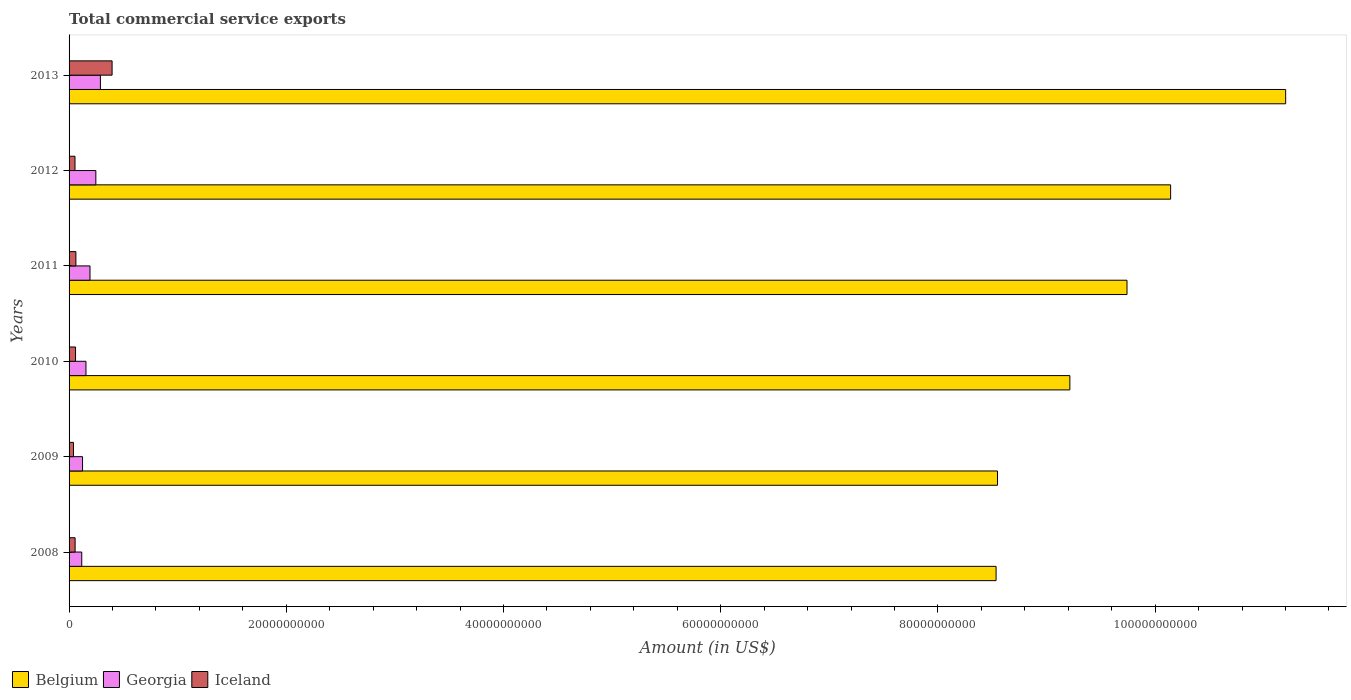Are the number of bars on each tick of the Y-axis equal?
Ensure brevity in your answer.  Yes. How many bars are there on the 5th tick from the top?
Provide a succinct answer. 3. How many bars are there on the 1st tick from the bottom?
Your answer should be compact. 3. What is the total commercial service exports in Iceland in 2010?
Ensure brevity in your answer.  5.96e+08. Across all years, what is the maximum total commercial service exports in Belgium?
Keep it short and to the point. 1.12e+11. Across all years, what is the minimum total commercial service exports in Georgia?
Your answer should be compact. 1.17e+09. In which year was the total commercial service exports in Belgium minimum?
Provide a short and direct response. 2008. What is the total total commercial service exports in Belgium in the graph?
Make the answer very short. 5.74e+11. What is the difference between the total commercial service exports in Belgium in 2009 and that in 2011?
Provide a succinct answer. -1.19e+1. What is the difference between the total commercial service exports in Georgia in 2010 and the total commercial service exports in Belgium in 2009?
Provide a short and direct response. -8.39e+1. What is the average total commercial service exports in Belgium per year?
Provide a short and direct response. 9.56e+1. In the year 2009, what is the difference between the total commercial service exports in Iceland and total commercial service exports in Georgia?
Ensure brevity in your answer.  -8.35e+08. In how many years, is the total commercial service exports in Iceland greater than 76000000000 US$?
Your answer should be very brief. 0. What is the ratio of the total commercial service exports in Belgium in 2011 to that in 2013?
Your response must be concise. 0.87. Is the total commercial service exports in Belgium in 2010 less than that in 2012?
Make the answer very short. Yes. What is the difference between the highest and the second highest total commercial service exports in Iceland?
Offer a terse response. 3.33e+09. What is the difference between the highest and the lowest total commercial service exports in Belgium?
Ensure brevity in your answer.  2.67e+1. What does the 1st bar from the bottom in 2012 represents?
Your answer should be very brief. Belgium. Are all the bars in the graph horizontal?
Provide a short and direct response. Yes. How many years are there in the graph?
Make the answer very short. 6. Are the values on the major ticks of X-axis written in scientific E-notation?
Offer a very short reply. No. Does the graph contain any zero values?
Provide a succinct answer. No. Does the graph contain grids?
Provide a short and direct response. No. How many legend labels are there?
Keep it short and to the point. 3. How are the legend labels stacked?
Offer a very short reply. Horizontal. What is the title of the graph?
Provide a succinct answer. Total commercial service exports. What is the Amount (in US$) of Belgium in 2008?
Offer a very short reply. 8.54e+1. What is the Amount (in US$) of Georgia in 2008?
Provide a short and direct response. 1.17e+09. What is the Amount (in US$) of Iceland in 2008?
Make the answer very short. 5.57e+08. What is the Amount (in US$) in Belgium in 2009?
Make the answer very short. 8.55e+1. What is the Amount (in US$) of Georgia in 2009?
Offer a terse response. 1.24e+09. What is the Amount (in US$) in Iceland in 2009?
Provide a succinct answer. 4.06e+08. What is the Amount (in US$) of Belgium in 2010?
Your answer should be very brief. 9.21e+1. What is the Amount (in US$) in Georgia in 2010?
Give a very brief answer. 1.56e+09. What is the Amount (in US$) of Iceland in 2010?
Offer a terse response. 5.96e+08. What is the Amount (in US$) of Belgium in 2011?
Provide a succinct answer. 9.74e+1. What is the Amount (in US$) in Georgia in 2011?
Give a very brief answer. 1.93e+09. What is the Amount (in US$) in Iceland in 2011?
Ensure brevity in your answer.  6.29e+08. What is the Amount (in US$) in Belgium in 2012?
Your response must be concise. 1.01e+11. What is the Amount (in US$) of Georgia in 2012?
Your answer should be very brief. 2.47e+09. What is the Amount (in US$) of Iceland in 2012?
Ensure brevity in your answer.  5.46e+08. What is the Amount (in US$) of Belgium in 2013?
Your answer should be very brief. 1.12e+11. What is the Amount (in US$) in Georgia in 2013?
Make the answer very short. 2.89e+09. What is the Amount (in US$) of Iceland in 2013?
Your answer should be very brief. 3.96e+09. Across all years, what is the maximum Amount (in US$) in Belgium?
Your answer should be compact. 1.12e+11. Across all years, what is the maximum Amount (in US$) in Georgia?
Make the answer very short. 2.89e+09. Across all years, what is the maximum Amount (in US$) of Iceland?
Provide a succinct answer. 3.96e+09. Across all years, what is the minimum Amount (in US$) in Belgium?
Your answer should be very brief. 8.54e+1. Across all years, what is the minimum Amount (in US$) of Georgia?
Your answer should be very brief. 1.17e+09. Across all years, what is the minimum Amount (in US$) in Iceland?
Ensure brevity in your answer.  4.06e+08. What is the total Amount (in US$) in Belgium in the graph?
Your response must be concise. 5.74e+11. What is the total Amount (in US$) in Georgia in the graph?
Your answer should be compact. 1.12e+1. What is the total Amount (in US$) in Iceland in the graph?
Offer a very short reply. 6.69e+09. What is the difference between the Amount (in US$) of Belgium in 2008 and that in 2009?
Your response must be concise. -1.30e+08. What is the difference between the Amount (in US$) of Georgia in 2008 and that in 2009?
Provide a succinct answer. -7.37e+07. What is the difference between the Amount (in US$) in Iceland in 2008 and that in 2009?
Make the answer very short. 1.51e+08. What is the difference between the Amount (in US$) in Belgium in 2008 and that in 2010?
Give a very brief answer. -6.79e+09. What is the difference between the Amount (in US$) of Georgia in 2008 and that in 2010?
Offer a terse response. -3.89e+08. What is the difference between the Amount (in US$) of Iceland in 2008 and that in 2010?
Offer a terse response. -3.97e+07. What is the difference between the Amount (in US$) of Belgium in 2008 and that in 2011?
Your answer should be compact. -1.21e+1. What is the difference between the Amount (in US$) in Georgia in 2008 and that in 2011?
Ensure brevity in your answer.  -7.60e+08. What is the difference between the Amount (in US$) of Iceland in 2008 and that in 2011?
Make the answer very short. -7.21e+07. What is the difference between the Amount (in US$) in Belgium in 2008 and that in 2012?
Provide a short and direct response. -1.61e+1. What is the difference between the Amount (in US$) in Georgia in 2008 and that in 2012?
Give a very brief answer. -1.30e+09. What is the difference between the Amount (in US$) in Iceland in 2008 and that in 2012?
Your answer should be very brief. 1.03e+07. What is the difference between the Amount (in US$) of Belgium in 2008 and that in 2013?
Your answer should be very brief. -2.67e+1. What is the difference between the Amount (in US$) of Georgia in 2008 and that in 2013?
Your response must be concise. -1.72e+09. What is the difference between the Amount (in US$) of Iceland in 2008 and that in 2013?
Your answer should be compact. -3.40e+09. What is the difference between the Amount (in US$) in Belgium in 2009 and that in 2010?
Offer a terse response. -6.66e+09. What is the difference between the Amount (in US$) in Georgia in 2009 and that in 2010?
Ensure brevity in your answer.  -3.15e+08. What is the difference between the Amount (in US$) of Iceland in 2009 and that in 2010?
Ensure brevity in your answer.  -1.91e+08. What is the difference between the Amount (in US$) in Belgium in 2009 and that in 2011?
Your answer should be compact. -1.19e+1. What is the difference between the Amount (in US$) of Georgia in 2009 and that in 2011?
Provide a succinct answer. -6.86e+08. What is the difference between the Amount (in US$) in Iceland in 2009 and that in 2011?
Your response must be concise. -2.23e+08. What is the difference between the Amount (in US$) of Belgium in 2009 and that in 2012?
Your response must be concise. -1.59e+1. What is the difference between the Amount (in US$) of Georgia in 2009 and that in 2012?
Offer a terse response. -1.22e+09. What is the difference between the Amount (in US$) of Iceland in 2009 and that in 2012?
Keep it short and to the point. -1.41e+08. What is the difference between the Amount (in US$) of Belgium in 2009 and that in 2013?
Provide a succinct answer. -2.65e+1. What is the difference between the Amount (in US$) of Georgia in 2009 and that in 2013?
Offer a very short reply. -1.64e+09. What is the difference between the Amount (in US$) of Iceland in 2009 and that in 2013?
Make the answer very short. -3.56e+09. What is the difference between the Amount (in US$) in Belgium in 2010 and that in 2011?
Ensure brevity in your answer.  -5.26e+09. What is the difference between the Amount (in US$) of Georgia in 2010 and that in 2011?
Your response must be concise. -3.71e+08. What is the difference between the Amount (in US$) of Iceland in 2010 and that in 2011?
Offer a terse response. -3.24e+07. What is the difference between the Amount (in US$) of Belgium in 2010 and that in 2012?
Offer a very short reply. -9.28e+09. What is the difference between the Amount (in US$) of Georgia in 2010 and that in 2012?
Your answer should be very brief. -9.09e+08. What is the difference between the Amount (in US$) of Iceland in 2010 and that in 2012?
Your answer should be very brief. 5.00e+07. What is the difference between the Amount (in US$) in Belgium in 2010 and that in 2013?
Give a very brief answer. -1.99e+1. What is the difference between the Amount (in US$) in Georgia in 2010 and that in 2013?
Provide a short and direct response. -1.33e+09. What is the difference between the Amount (in US$) in Iceland in 2010 and that in 2013?
Your answer should be compact. -3.37e+09. What is the difference between the Amount (in US$) in Belgium in 2011 and that in 2012?
Make the answer very short. -4.02e+09. What is the difference between the Amount (in US$) in Georgia in 2011 and that in 2012?
Provide a short and direct response. -5.38e+08. What is the difference between the Amount (in US$) of Iceland in 2011 and that in 2012?
Provide a succinct answer. 8.24e+07. What is the difference between the Amount (in US$) in Belgium in 2011 and that in 2013?
Offer a very short reply. -1.46e+1. What is the difference between the Amount (in US$) of Georgia in 2011 and that in 2013?
Make the answer very short. -9.58e+08. What is the difference between the Amount (in US$) in Iceland in 2011 and that in 2013?
Your answer should be compact. -3.33e+09. What is the difference between the Amount (in US$) of Belgium in 2012 and that in 2013?
Provide a short and direct response. -1.06e+1. What is the difference between the Amount (in US$) in Georgia in 2012 and that in 2013?
Provide a short and direct response. -4.20e+08. What is the difference between the Amount (in US$) in Iceland in 2012 and that in 2013?
Keep it short and to the point. -3.42e+09. What is the difference between the Amount (in US$) in Belgium in 2008 and the Amount (in US$) in Georgia in 2009?
Make the answer very short. 8.41e+1. What is the difference between the Amount (in US$) in Belgium in 2008 and the Amount (in US$) in Iceland in 2009?
Keep it short and to the point. 8.49e+1. What is the difference between the Amount (in US$) in Georgia in 2008 and the Amount (in US$) in Iceland in 2009?
Offer a very short reply. 7.61e+08. What is the difference between the Amount (in US$) in Belgium in 2008 and the Amount (in US$) in Georgia in 2010?
Provide a short and direct response. 8.38e+1. What is the difference between the Amount (in US$) of Belgium in 2008 and the Amount (in US$) of Iceland in 2010?
Your response must be concise. 8.48e+1. What is the difference between the Amount (in US$) in Georgia in 2008 and the Amount (in US$) in Iceland in 2010?
Make the answer very short. 5.71e+08. What is the difference between the Amount (in US$) of Belgium in 2008 and the Amount (in US$) of Georgia in 2011?
Keep it short and to the point. 8.34e+1. What is the difference between the Amount (in US$) in Belgium in 2008 and the Amount (in US$) in Iceland in 2011?
Provide a short and direct response. 8.47e+1. What is the difference between the Amount (in US$) in Georgia in 2008 and the Amount (in US$) in Iceland in 2011?
Provide a succinct answer. 5.38e+08. What is the difference between the Amount (in US$) of Belgium in 2008 and the Amount (in US$) of Georgia in 2012?
Offer a very short reply. 8.29e+1. What is the difference between the Amount (in US$) of Belgium in 2008 and the Amount (in US$) of Iceland in 2012?
Keep it short and to the point. 8.48e+1. What is the difference between the Amount (in US$) in Georgia in 2008 and the Amount (in US$) in Iceland in 2012?
Give a very brief answer. 6.21e+08. What is the difference between the Amount (in US$) in Belgium in 2008 and the Amount (in US$) in Georgia in 2013?
Give a very brief answer. 8.25e+1. What is the difference between the Amount (in US$) in Belgium in 2008 and the Amount (in US$) in Iceland in 2013?
Offer a very short reply. 8.14e+1. What is the difference between the Amount (in US$) in Georgia in 2008 and the Amount (in US$) in Iceland in 2013?
Your answer should be compact. -2.79e+09. What is the difference between the Amount (in US$) in Belgium in 2009 and the Amount (in US$) in Georgia in 2010?
Give a very brief answer. 8.39e+1. What is the difference between the Amount (in US$) of Belgium in 2009 and the Amount (in US$) of Iceland in 2010?
Give a very brief answer. 8.49e+1. What is the difference between the Amount (in US$) of Georgia in 2009 and the Amount (in US$) of Iceland in 2010?
Offer a terse response. 6.45e+08. What is the difference between the Amount (in US$) in Belgium in 2009 and the Amount (in US$) in Georgia in 2011?
Offer a terse response. 8.36e+1. What is the difference between the Amount (in US$) of Belgium in 2009 and the Amount (in US$) of Iceland in 2011?
Provide a succinct answer. 8.49e+1. What is the difference between the Amount (in US$) of Georgia in 2009 and the Amount (in US$) of Iceland in 2011?
Make the answer very short. 6.12e+08. What is the difference between the Amount (in US$) of Belgium in 2009 and the Amount (in US$) of Georgia in 2012?
Provide a succinct answer. 8.30e+1. What is the difference between the Amount (in US$) in Belgium in 2009 and the Amount (in US$) in Iceland in 2012?
Ensure brevity in your answer.  8.49e+1. What is the difference between the Amount (in US$) of Georgia in 2009 and the Amount (in US$) of Iceland in 2012?
Keep it short and to the point. 6.95e+08. What is the difference between the Amount (in US$) of Belgium in 2009 and the Amount (in US$) of Georgia in 2013?
Offer a terse response. 8.26e+1. What is the difference between the Amount (in US$) of Belgium in 2009 and the Amount (in US$) of Iceland in 2013?
Offer a terse response. 8.15e+1. What is the difference between the Amount (in US$) of Georgia in 2009 and the Amount (in US$) of Iceland in 2013?
Give a very brief answer. -2.72e+09. What is the difference between the Amount (in US$) in Belgium in 2010 and the Amount (in US$) in Georgia in 2011?
Provide a short and direct response. 9.02e+1. What is the difference between the Amount (in US$) of Belgium in 2010 and the Amount (in US$) of Iceland in 2011?
Offer a very short reply. 9.15e+1. What is the difference between the Amount (in US$) in Georgia in 2010 and the Amount (in US$) in Iceland in 2011?
Provide a short and direct response. 9.28e+08. What is the difference between the Amount (in US$) in Belgium in 2010 and the Amount (in US$) in Georgia in 2012?
Your answer should be very brief. 8.97e+1. What is the difference between the Amount (in US$) of Belgium in 2010 and the Amount (in US$) of Iceland in 2012?
Your answer should be very brief. 9.16e+1. What is the difference between the Amount (in US$) of Georgia in 2010 and the Amount (in US$) of Iceland in 2012?
Provide a succinct answer. 1.01e+09. What is the difference between the Amount (in US$) of Belgium in 2010 and the Amount (in US$) of Georgia in 2013?
Your answer should be very brief. 8.93e+1. What is the difference between the Amount (in US$) in Belgium in 2010 and the Amount (in US$) in Iceland in 2013?
Your response must be concise. 8.82e+1. What is the difference between the Amount (in US$) in Georgia in 2010 and the Amount (in US$) in Iceland in 2013?
Give a very brief answer. -2.41e+09. What is the difference between the Amount (in US$) of Belgium in 2011 and the Amount (in US$) of Georgia in 2012?
Provide a succinct answer. 9.49e+1. What is the difference between the Amount (in US$) in Belgium in 2011 and the Amount (in US$) in Iceland in 2012?
Offer a very short reply. 9.69e+1. What is the difference between the Amount (in US$) of Georgia in 2011 and the Amount (in US$) of Iceland in 2012?
Keep it short and to the point. 1.38e+09. What is the difference between the Amount (in US$) in Belgium in 2011 and the Amount (in US$) in Georgia in 2013?
Give a very brief answer. 9.45e+1. What is the difference between the Amount (in US$) in Belgium in 2011 and the Amount (in US$) in Iceland in 2013?
Keep it short and to the point. 9.34e+1. What is the difference between the Amount (in US$) in Georgia in 2011 and the Amount (in US$) in Iceland in 2013?
Your answer should be compact. -2.03e+09. What is the difference between the Amount (in US$) of Belgium in 2012 and the Amount (in US$) of Georgia in 2013?
Ensure brevity in your answer.  9.85e+1. What is the difference between the Amount (in US$) in Belgium in 2012 and the Amount (in US$) in Iceland in 2013?
Provide a succinct answer. 9.75e+1. What is the difference between the Amount (in US$) of Georgia in 2012 and the Amount (in US$) of Iceland in 2013?
Ensure brevity in your answer.  -1.50e+09. What is the average Amount (in US$) in Belgium per year?
Provide a short and direct response. 9.56e+1. What is the average Amount (in US$) in Georgia per year?
Give a very brief answer. 1.87e+09. What is the average Amount (in US$) in Iceland per year?
Offer a terse response. 1.12e+09. In the year 2008, what is the difference between the Amount (in US$) in Belgium and Amount (in US$) in Georgia?
Ensure brevity in your answer.  8.42e+1. In the year 2008, what is the difference between the Amount (in US$) in Belgium and Amount (in US$) in Iceland?
Offer a terse response. 8.48e+1. In the year 2008, what is the difference between the Amount (in US$) of Georgia and Amount (in US$) of Iceland?
Ensure brevity in your answer.  6.11e+08. In the year 2009, what is the difference between the Amount (in US$) in Belgium and Amount (in US$) in Georgia?
Provide a succinct answer. 8.42e+1. In the year 2009, what is the difference between the Amount (in US$) of Belgium and Amount (in US$) of Iceland?
Your response must be concise. 8.51e+1. In the year 2009, what is the difference between the Amount (in US$) of Georgia and Amount (in US$) of Iceland?
Provide a succinct answer. 8.35e+08. In the year 2010, what is the difference between the Amount (in US$) in Belgium and Amount (in US$) in Georgia?
Offer a very short reply. 9.06e+1. In the year 2010, what is the difference between the Amount (in US$) in Belgium and Amount (in US$) in Iceland?
Keep it short and to the point. 9.15e+1. In the year 2010, what is the difference between the Amount (in US$) in Georgia and Amount (in US$) in Iceland?
Offer a terse response. 9.60e+08. In the year 2011, what is the difference between the Amount (in US$) of Belgium and Amount (in US$) of Georgia?
Your answer should be very brief. 9.55e+1. In the year 2011, what is the difference between the Amount (in US$) in Belgium and Amount (in US$) in Iceland?
Your answer should be compact. 9.68e+1. In the year 2011, what is the difference between the Amount (in US$) in Georgia and Amount (in US$) in Iceland?
Provide a succinct answer. 1.30e+09. In the year 2012, what is the difference between the Amount (in US$) in Belgium and Amount (in US$) in Georgia?
Provide a short and direct response. 9.90e+1. In the year 2012, what is the difference between the Amount (in US$) in Belgium and Amount (in US$) in Iceland?
Ensure brevity in your answer.  1.01e+11. In the year 2012, what is the difference between the Amount (in US$) in Georgia and Amount (in US$) in Iceland?
Make the answer very short. 1.92e+09. In the year 2013, what is the difference between the Amount (in US$) in Belgium and Amount (in US$) in Georgia?
Provide a short and direct response. 1.09e+11. In the year 2013, what is the difference between the Amount (in US$) in Belgium and Amount (in US$) in Iceland?
Your response must be concise. 1.08e+11. In the year 2013, what is the difference between the Amount (in US$) of Georgia and Amount (in US$) of Iceland?
Provide a short and direct response. -1.08e+09. What is the ratio of the Amount (in US$) of Belgium in 2008 to that in 2009?
Offer a terse response. 1. What is the ratio of the Amount (in US$) of Georgia in 2008 to that in 2009?
Give a very brief answer. 0.94. What is the ratio of the Amount (in US$) in Iceland in 2008 to that in 2009?
Your answer should be compact. 1.37. What is the ratio of the Amount (in US$) of Belgium in 2008 to that in 2010?
Offer a very short reply. 0.93. What is the ratio of the Amount (in US$) of Georgia in 2008 to that in 2010?
Ensure brevity in your answer.  0.75. What is the ratio of the Amount (in US$) of Iceland in 2008 to that in 2010?
Give a very brief answer. 0.93. What is the ratio of the Amount (in US$) in Belgium in 2008 to that in 2011?
Your response must be concise. 0.88. What is the ratio of the Amount (in US$) in Georgia in 2008 to that in 2011?
Provide a short and direct response. 0.61. What is the ratio of the Amount (in US$) of Iceland in 2008 to that in 2011?
Provide a short and direct response. 0.89. What is the ratio of the Amount (in US$) of Belgium in 2008 to that in 2012?
Offer a very short reply. 0.84. What is the ratio of the Amount (in US$) of Georgia in 2008 to that in 2012?
Offer a terse response. 0.47. What is the ratio of the Amount (in US$) in Iceland in 2008 to that in 2012?
Provide a succinct answer. 1.02. What is the ratio of the Amount (in US$) in Belgium in 2008 to that in 2013?
Give a very brief answer. 0.76. What is the ratio of the Amount (in US$) in Georgia in 2008 to that in 2013?
Offer a terse response. 0.4. What is the ratio of the Amount (in US$) in Iceland in 2008 to that in 2013?
Provide a short and direct response. 0.14. What is the ratio of the Amount (in US$) of Belgium in 2009 to that in 2010?
Your answer should be compact. 0.93. What is the ratio of the Amount (in US$) of Georgia in 2009 to that in 2010?
Keep it short and to the point. 0.8. What is the ratio of the Amount (in US$) of Iceland in 2009 to that in 2010?
Keep it short and to the point. 0.68. What is the ratio of the Amount (in US$) of Belgium in 2009 to that in 2011?
Provide a short and direct response. 0.88. What is the ratio of the Amount (in US$) in Georgia in 2009 to that in 2011?
Give a very brief answer. 0.64. What is the ratio of the Amount (in US$) in Iceland in 2009 to that in 2011?
Offer a terse response. 0.65. What is the ratio of the Amount (in US$) of Belgium in 2009 to that in 2012?
Keep it short and to the point. 0.84. What is the ratio of the Amount (in US$) in Georgia in 2009 to that in 2012?
Offer a very short reply. 0.5. What is the ratio of the Amount (in US$) in Iceland in 2009 to that in 2012?
Provide a succinct answer. 0.74. What is the ratio of the Amount (in US$) of Belgium in 2009 to that in 2013?
Your answer should be very brief. 0.76. What is the ratio of the Amount (in US$) of Georgia in 2009 to that in 2013?
Provide a short and direct response. 0.43. What is the ratio of the Amount (in US$) of Iceland in 2009 to that in 2013?
Your response must be concise. 0.1. What is the ratio of the Amount (in US$) of Belgium in 2010 to that in 2011?
Provide a short and direct response. 0.95. What is the ratio of the Amount (in US$) in Georgia in 2010 to that in 2011?
Your answer should be very brief. 0.81. What is the ratio of the Amount (in US$) of Iceland in 2010 to that in 2011?
Offer a very short reply. 0.95. What is the ratio of the Amount (in US$) in Belgium in 2010 to that in 2012?
Ensure brevity in your answer.  0.91. What is the ratio of the Amount (in US$) of Georgia in 2010 to that in 2012?
Provide a succinct answer. 0.63. What is the ratio of the Amount (in US$) of Iceland in 2010 to that in 2012?
Offer a terse response. 1.09. What is the ratio of the Amount (in US$) of Belgium in 2010 to that in 2013?
Offer a very short reply. 0.82. What is the ratio of the Amount (in US$) in Georgia in 2010 to that in 2013?
Keep it short and to the point. 0.54. What is the ratio of the Amount (in US$) of Iceland in 2010 to that in 2013?
Provide a succinct answer. 0.15. What is the ratio of the Amount (in US$) of Belgium in 2011 to that in 2012?
Provide a succinct answer. 0.96. What is the ratio of the Amount (in US$) of Georgia in 2011 to that in 2012?
Provide a succinct answer. 0.78. What is the ratio of the Amount (in US$) of Iceland in 2011 to that in 2012?
Offer a very short reply. 1.15. What is the ratio of the Amount (in US$) of Belgium in 2011 to that in 2013?
Provide a succinct answer. 0.87. What is the ratio of the Amount (in US$) in Georgia in 2011 to that in 2013?
Make the answer very short. 0.67. What is the ratio of the Amount (in US$) of Iceland in 2011 to that in 2013?
Make the answer very short. 0.16. What is the ratio of the Amount (in US$) of Belgium in 2012 to that in 2013?
Offer a very short reply. 0.91. What is the ratio of the Amount (in US$) in Georgia in 2012 to that in 2013?
Provide a short and direct response. 0.85. What is the ratio of the Amount (in US$) of Iceland in 2012 to that in 2013?
Offer a very short reply. 0.14. What is the difference between the highest and the second highest Amount (in US$) in Belgium?
Provide a succinct answer. 1.06e+1. What is the difference between the highest and the second highest Amount (in US$) in Georgia?
Make the answer very short. 4.20e+08. What is the difference between the highest and the second highest Amount (in US$) in Iceland?
Your response must be concise. 3.33e+09. What is the difference between the highest and the lowest Amount (in US$) in Belgium?
Keep it short and to the point. 2.67e+1. What is the difference between the highest and the lowest Amount (in US$) of Georgia?
Offer a very short reply. 1.72e+09. What is the difference between the highest and the lowest Amount (in US$) of Iceland?
Make the answer very short. 3.56e+09. 